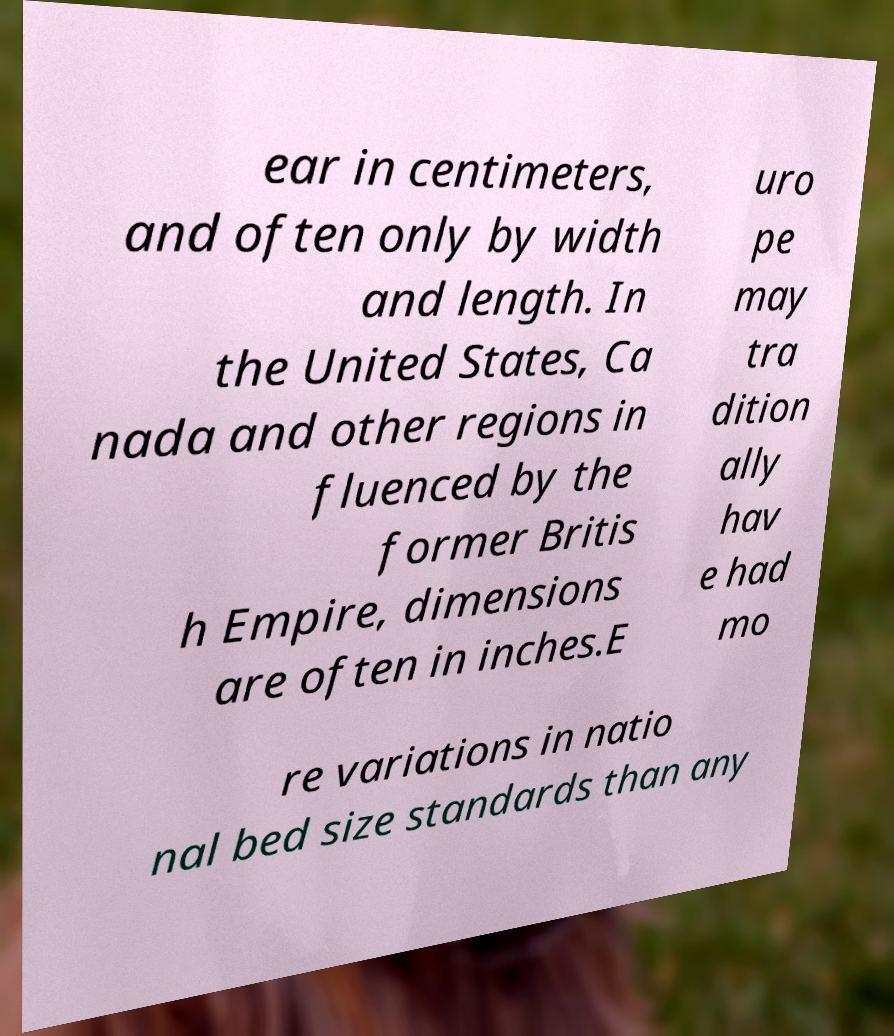I need the written content from this picture converted into text. Can you do that? ear in centimeters, and often only by width and length. In the United States, Ca nada and other regions in fluenced by the former Britis h Empire, dimensions are often in inches.E uro pe may tra dition ally hav e had mo re variations in natio nal bed size standards than any 